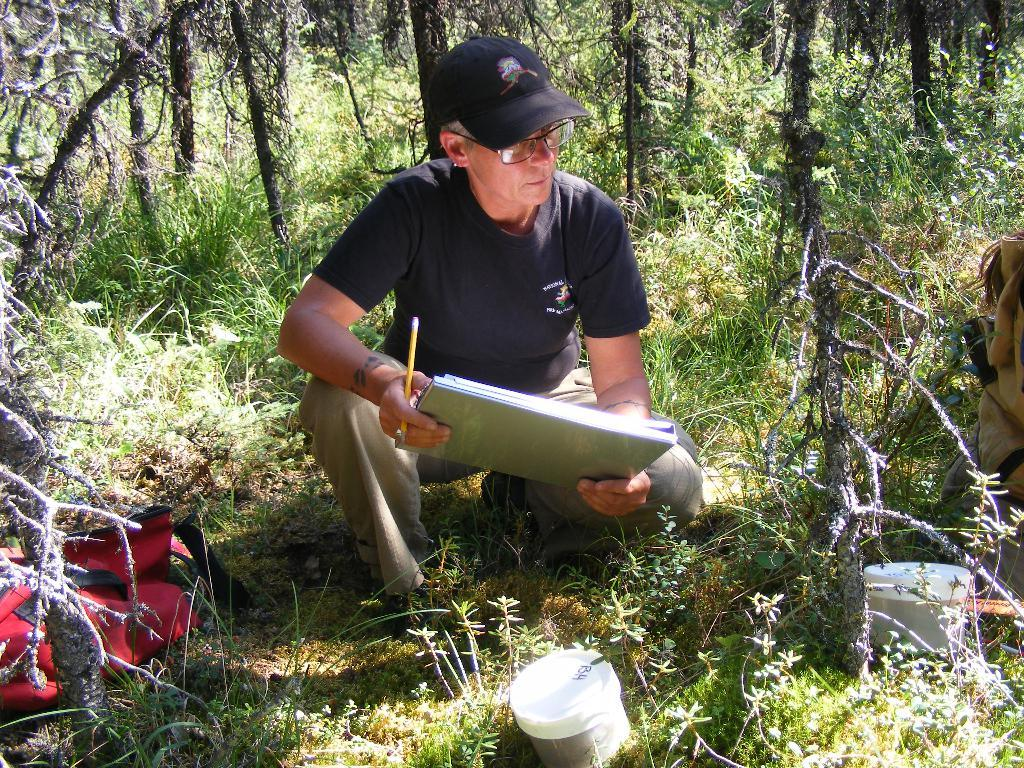What is the man in the image doing? The man is sitting on the grass in the image. What is the man holding in his hands? The man is holding stationary in his hands. What can be seen in the background of the image? There are trees, plants, grass, a bag, and storage boxes in the background of the image. How does the man in the image contribute to pollution? There is no indication in the image that the man is contributing to pollution. What type of memory does the man in the image have? There is no information about the man's memory in the image. 